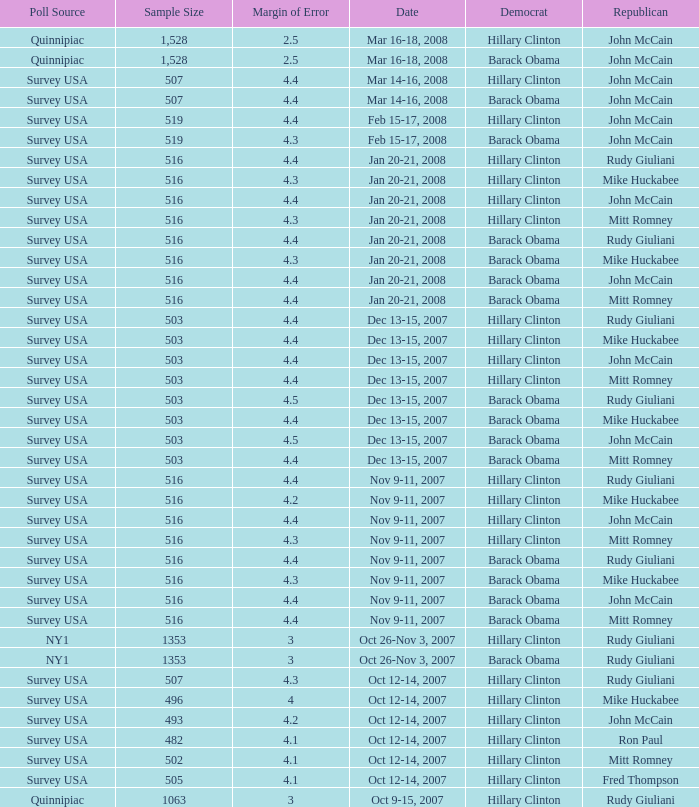In the poll with a sample size less than 516, which democrat was chosen alongside republican ron paul? Hillary Clinton. 